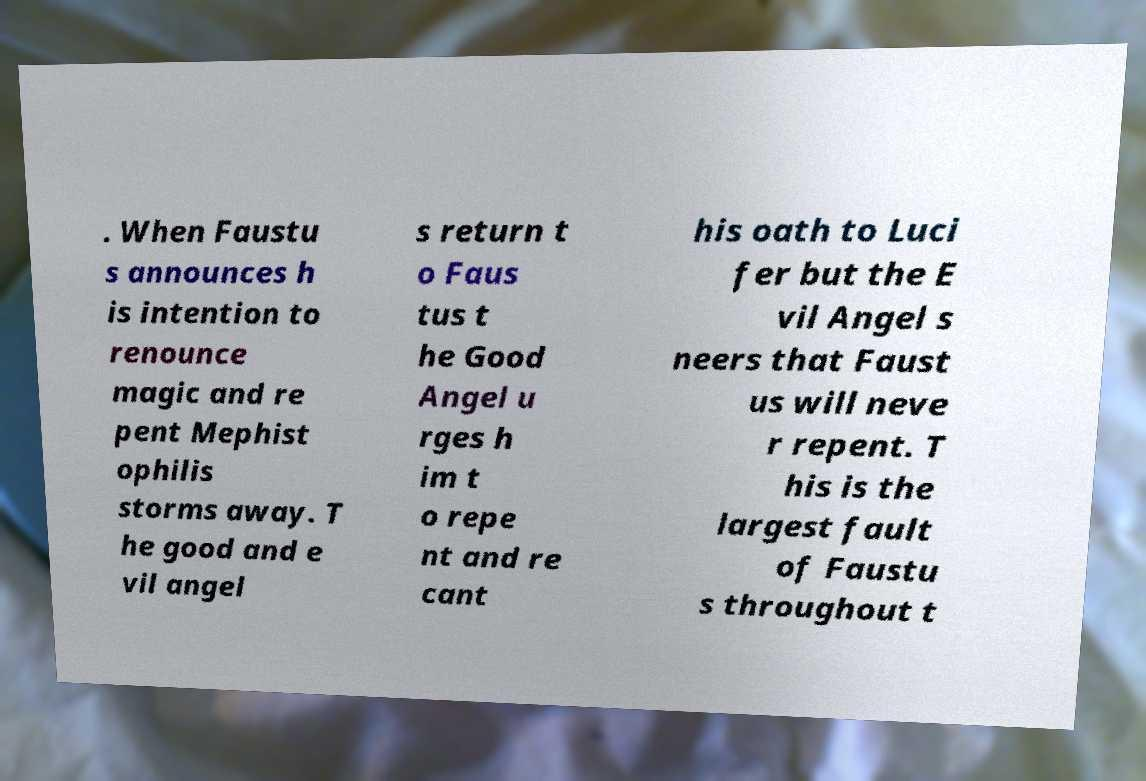There's text embedded in this image that I need extracted. Can you transcribe it verbatim? . When Faustu s announces h is intention to renounce magic and re pent Mephist ophilis storms away. T he good and e vil angel s return t o Faus tus t he Good Angel u rges h im t o repe nt and re cant his oath to Luci fer but the E vil Angel s neers that Faust us will neve r repent. T his is the largest fault of Faustu s throughout t 